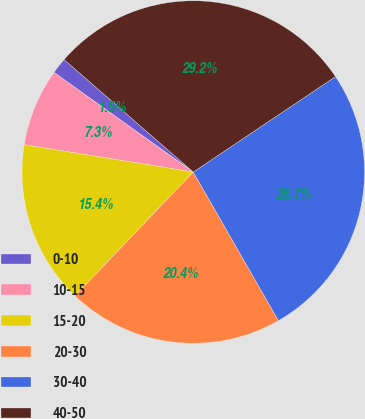Convert chart. <chart><loc_0><loc_0><loc_500><loc_500><pie_chart><fcel>0-10<fcel>10-15<fcel>15-20<fcel>20-30<fcel>30-40<fcel>40-50<nl><fcel>1.52%<fcel>7.33%<fcel>15.41%<fcel>20.42%<fcel>26.12%<fcel>29.19%<nl></chart> 